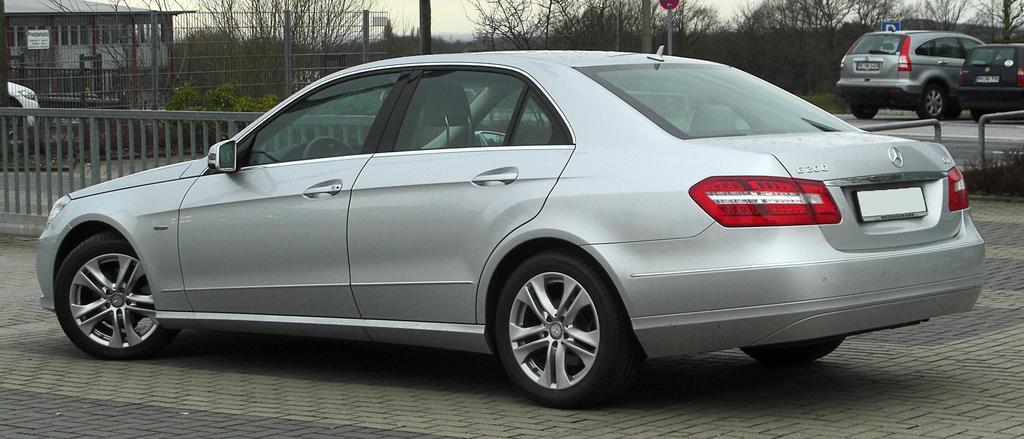How would you summarize this image in a sentence or two? In this image on the road there are few vehicles. Here there is a fence. In the background there are trees, building, boundary, poles and sign board. 